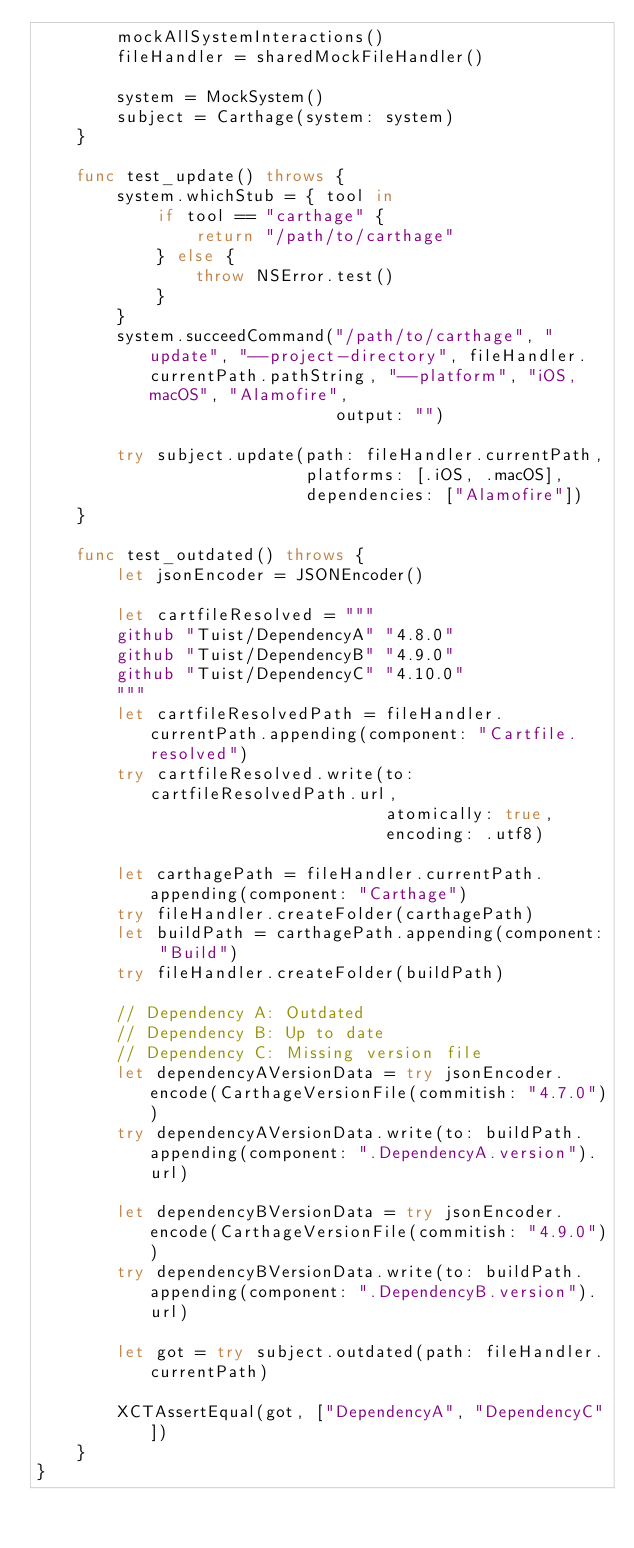Convert code to text. <code><loc_0><loc_0><loc_500><loc_500><_Swift_>        mockAllSystemInteractions()
        fileHandler = sharedMockFileHandler()

        system = MockSystem()
        subject = Carthage(system: system)
    }

    func test_update() throws {
        system.whichStub = { tool in
            if tool == "carthage" {
                return "/path/to/carthage"
            } else {
                throw NSError.test()
            }
        }
        system.succeedCommand("/path/to/carthage", "update", "--project-directory", fileHandler.currentPath.pathString, "--platform", "iOS,macOS", "Alamofire",
                              output: "")

        try subject.update(path: fileHandler.currentPath,
                           platforms: [.iOS, .macOS],
                           dependencies: ["Alamofire"])
    }

    func test_outdated() throws {
        let jsonEncoder = JSONEncoder()

        let cartfileResolved = """
        github "Tuist/DependencyA" "4.8.0"
        github "Tuist/DependencyB" "4.9.0"
        github "Tuist/DependencyC" "4.10.0"
        """
        let cartfileResolvedPath = fileHandler.currentPath.appending(component: "Cartfile.resolved")
        try cartfileResolved.write(to: cartfileResolvedPath.url,
                                   atomically: true,
                                   encoding: .utf8)

        let carthagePath = fileHandler.currentPath.appending(component: "Carthage")
        try fileHandler.createFolder(carthagePath)
        let buildPath = carthagePath.appending(component: "Build")
        try fileHandler.createFolder(buildPath)

        // Dependency A: Outdated
        // Dependency B: Up to date
        // Dependency C: Missing version file
        let dependencyAVersionData = try jsonEncoder.encode(CarthageVersionFile(commitish: "4.7.0"))
        try dependencyAVersionData.write(to: buildPath.appending(component: ".DependencyA.version").url)

        let dependencyBVersionData = try jsonEncoder.encode(CarthageVersionFile(commitish: "4.9.0"))
        try dependencyBVersionData.write(to: buildPath.appending(component: ".DependencyB.version").url)

        let got = try subject.outdated(path: fileHandler.currentPath)

        XCTAssertEqual(got, ["DependencyA", "DependencyC"])
    }
}
</code> 